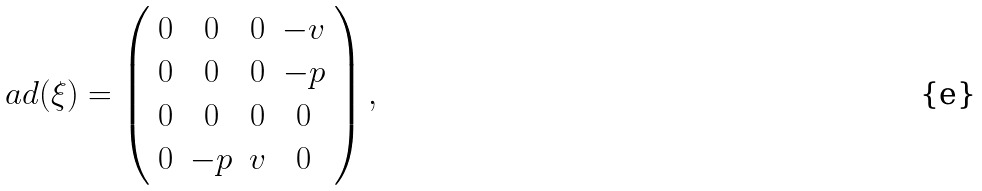<formula> <loc_0><loc_0><loc_500><loc_500>a d ( \xi ) = \left ( \begin{array} { c c c c } 0 & 0 & 0 & - v \\ 0 & 0 & 0 & - p \\ 0 & 0 & 0 & 0 \\ 0 & - p & v & 0 \\ \end{array} \right ) ,</formula> 